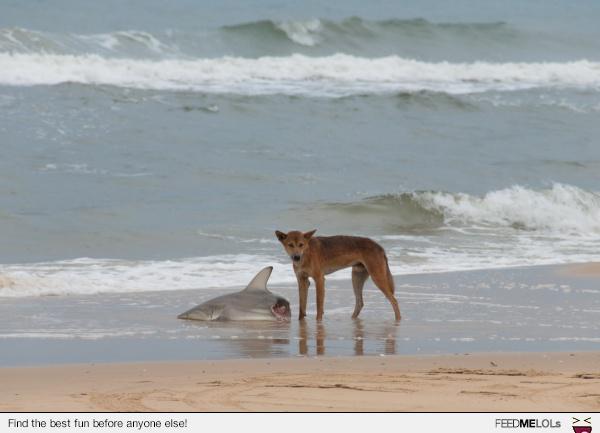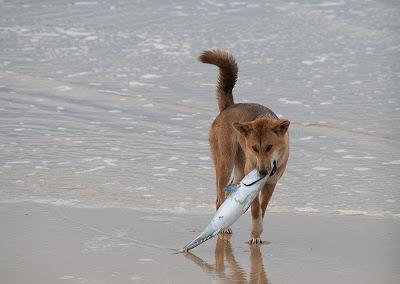The first image is the image on the left, the second image is the image on the right. For the images displayed, is the sentence "The front half of one shark is lying in the sand." factually correct? Answer yes or no. Yes. 